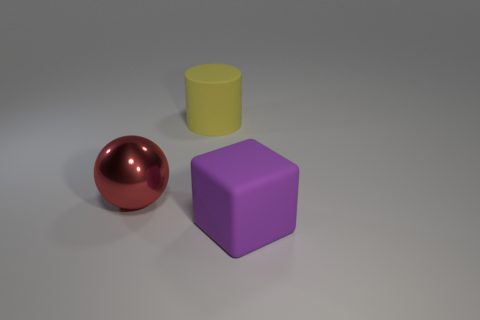Add 2 large red objects. How many objects exist? 5 Subtract all spheres. How many objects are left? 2 Subtract all large spheres. Subtract all yellow objects. How many objects are left? 1 Add 3 rubber cylinders. How many rubber cylinders are left? 4 Add 1 big green matte cubes. How many big green matte cubes exist? 1 Subtract 0 red blocks. How many objects are left? 3 